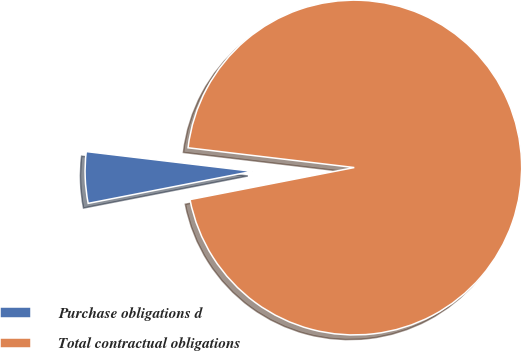<chart> <loc_0><loc_0><loc_500><loc_500><pie_chart><fcel>Purchase obligations d<fcel>Total contractual obligations<nl><fcel>4.95%<fcel>95.05%<nl></chart> 